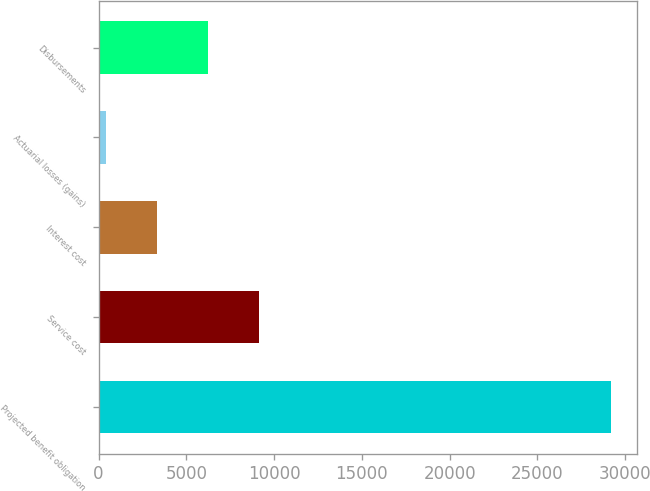<chart> <loc_0><loc_0><loc_500><loc_500><bar_chart><fcel>Projected benefit obligation<fcel>Service cost<fcel>Interest cost<fcel>Actuarial losses (gains)<fcel>Disbursements<nl><fcel>29195<fcel>9158.5<fcel>3345.5<fcel>439<fcel>6252<nl></chart> 